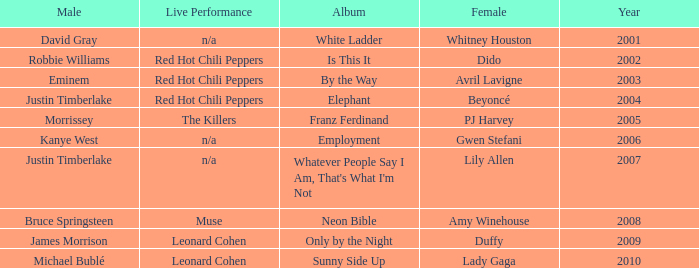Which male is paired with dido in 2004? Robbie Williams. 